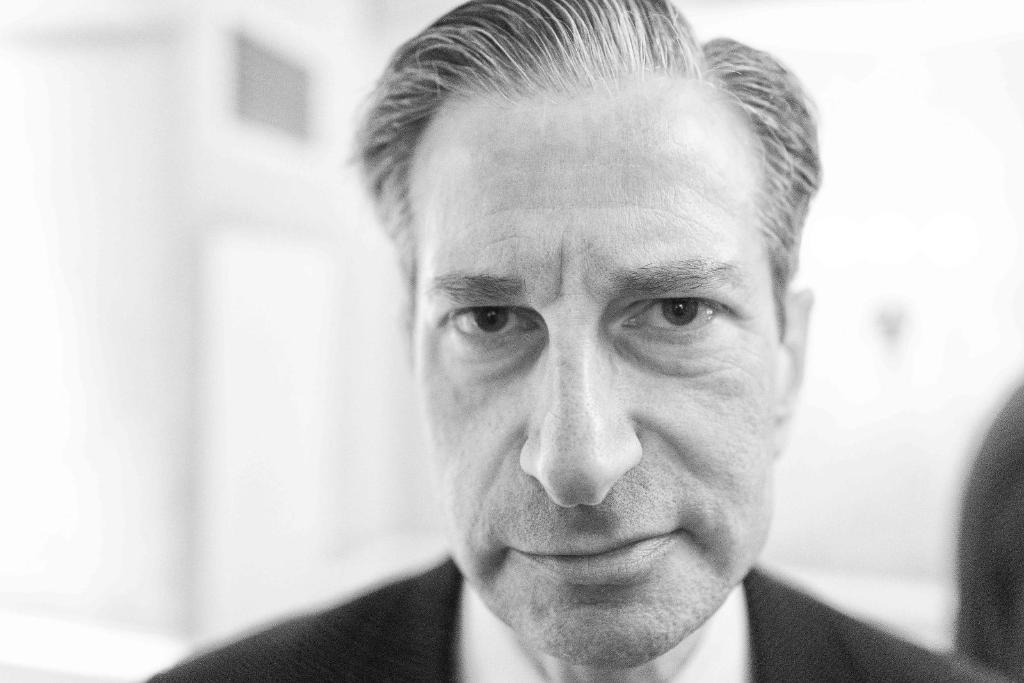Who is the main subject in the foreground of the image? There is a man in the foreground of the image. What is the man wearing? The man is wearing a suit. Can you describe the background of the image? The background of the image is blurred. What type of kite is being advertised in the background of the image? There is no kite or advertisement present in the image; it primarily features a man in the foreground wearing a suit. Where is the playground located in the image? There is no playground present in the image. 